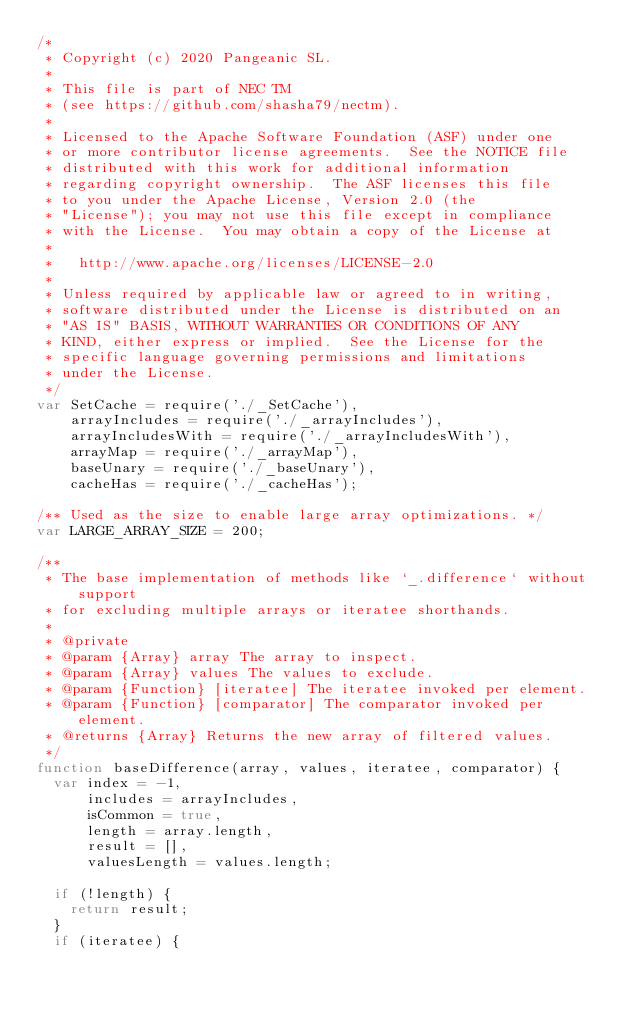<code> <loc_0><loc_0><loc_500><loc_500><_JavaScript_>/*
 * Copyright (c) 2020 Pangeanic SL.
 *
 * This file is part of NEC TM
 * (see https://github.com/shasha79/nectm).
 *
 * Licensed to the Apache Software Foundation (ASF) under one
 * or more contributor license agreements.  See the NOTICE file
 * distributed with this work for additional information
 * regarding copyright ownership.  The ASF licenses this file
 * to you under the Apache License, Version 2.0 (the
 * "License"); you may not use this file except in compliance
 * with the License.  You may obtain a copy of the License at
 *
 *   http://www.apache.org/licenses/LICENSE-2.0
 *
 * Unless required by applicable law or agreed to in writing,
 * software distributed under the License is distributed on an
 * "AS IS" BASIS, WITHOUT WARRANTIES OR CONDITIONS OF ANY
 * KIND, either express or implied.  See the License for the
 * specific language governing permissions and limitations
 * under the License.
 */
var SetCache = require('./_SetCache'),
    arrayIncludes = require('./_arrayIncludes'),
    arrayIncludesWith = require('./_arrayIncludesWith'),
    arrayMap = require('./_arrayMap'),
    baseUnary = require('./_baseUnary'),
    cacheHas = require('./_cacheHas');

/** Used as the size to enable large array optimizations. */
var LARGE_ARRAY_SIZE = 200;

/**
 * The base implementation of methods like `_.difference` without support
 * for excluding multiple arrays or iteratee shorthands.
 *
 * @private
 * @param {Array} array The array to inspect.
 * @param {Array} values The values to exclude.
 * @param {Function} [iteratee] The iteratee invoked per element.
 * @param {Function} [comparator] The comparator invoked per element.
 * @returns {Array} Returns the new array of filtered values.
 */
function baseDifference(array, values, iteratee, comparator) {
  var index = -1,
      includes = arrayIncludes,
      isCommon = true,
      length = array.length,
      result = [],
      valuesLength = values.length;

  if (!length) {
    return result;
  }
  if (iteratee) {</code> 